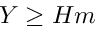<formula> <loc_0><loc_0><loc_500><loc_500>Y \geq H m</formula> 